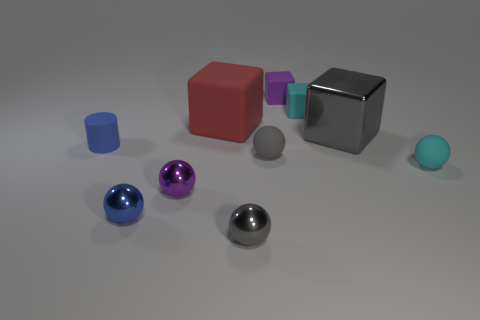Subtract all gray metallic cubes. How many cubes are left? 3 Subtract all brown cylinders. How many gray spheres are left? 2 Subtract all purple balls. How many balls are left? 4 Subtract all purple balls. Subtract all yellow cylinders. How many balls are left? 4 Subtract all cylinders. How many objects are left? 9 Subtract all large matte cylinders. Subtract all cyan matte blocks. How many objects are left? 9 Add 7 blue spheres. How many blue spheres are left? 8 Add 3 big cyan rubber things. How many big cyan rubber things exist? 3 Subtract 0 yellow cubes. How many objects are left? 10 